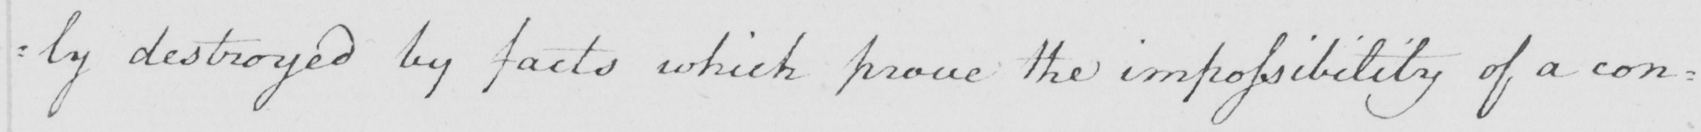What text is written in this handwritten line? : ly destroyed by facts which prove the impossibility of a con= 